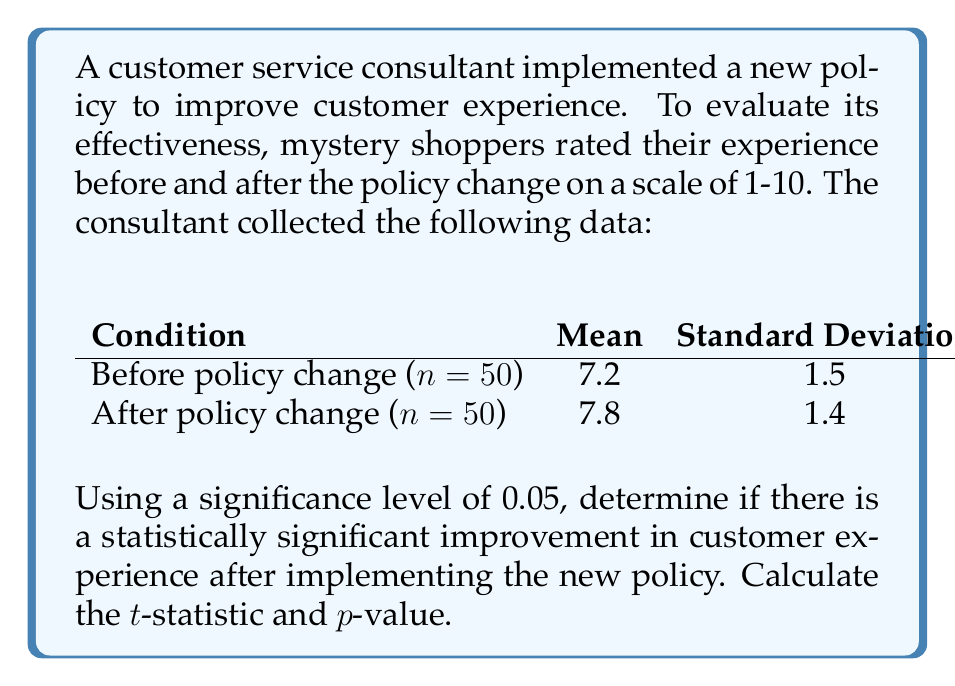Could you help me with this problem? To determine if there's a statistically significant improvement, we'll use a two-sample t-test.

Step 1: State the null and alternative hypotheses
$H_0: \mu_1 = \mu_2$ (no difference in means)
$H_a: \mu_1 < \mu_2$ (mean after is greater than mean before)

Step 2: Calculate the pooled standard deviation
$$s_p = \sqrt{\frac{(n_1-1)s_1^2 + (n_2-1)s_2^2}{n_1+n_2-2}}$$
$$s_p = \sqrt{\frac{(50-1)(1.5)^2 + (50-1)(1.4)^2}{50+50-2}} = 1.45$$

Step 3: Calculate the standard error of the difference between means
$$SE = s_p\sqrt{\frac{1}{n_1}+\frac{1}{n_2}} = 1.45\sqrt{\frac{1}{50}+\frac{1}{50}} = 0.29$$

Step 4: Calculate the t-statistic
$$t = \frac{\bar{x}_2 - \bar{x}_1}{SE} = \frac{7.8 - 7.2}{0.29} = 2.07$$

Step 5: Determine the degrees of freedom
$df = n_1 + n_2 - 2 = 50 + 50 - 2 = 98$

Step 6: Find the p-value
Using a t-distribution table or calculator with 98 degrees of freedom and a one-tailed test, we find:
$p-value \approx 0.0205$

Step 7: Compare p-value to significance level
Since $0.0205 < 0.05$, we reject the null hypothesis.
Answer: t-statistic = 2.07, p-value = 0.0205. Statistically significant improvement. 